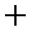<formula> <loc_0><loc_0><loc_500><loc_500>^ { + }</formula> 